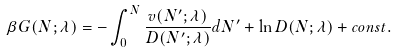<formula> <loc_0><loc_0><loc_500><loc_500>\beta G ( N ; \lambda ) = - \int _ { 0 } ^ { N } \frac { v ( N ^ { \prime } ; \lambda ) } { D ( N ^ { \prime } ; \lambda ) } d N ^ { \prime } + \ln D ( N ; \lambda ) + c o n s t .</formula> 